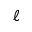Convert formula to latex. <formula><loc_0><loc_0><loc_500><loc_500>\ell</formula> 